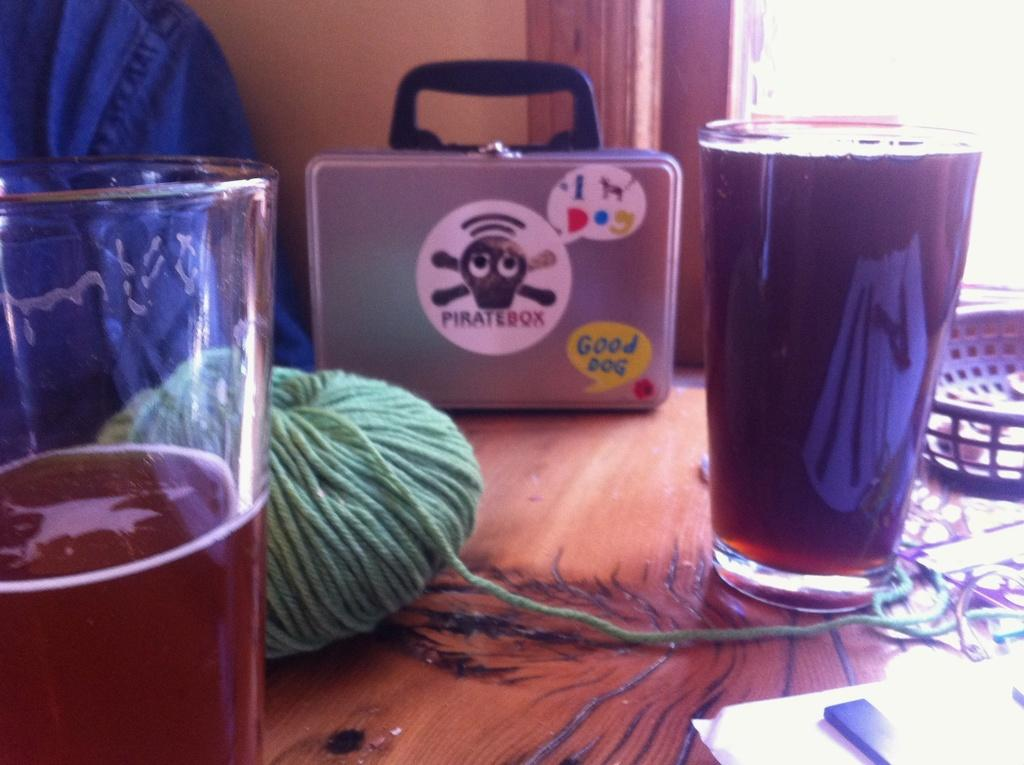<image>
Render a clear and concise summary of the photo. 2 glasses of beer and box of pirate box sit on the table 